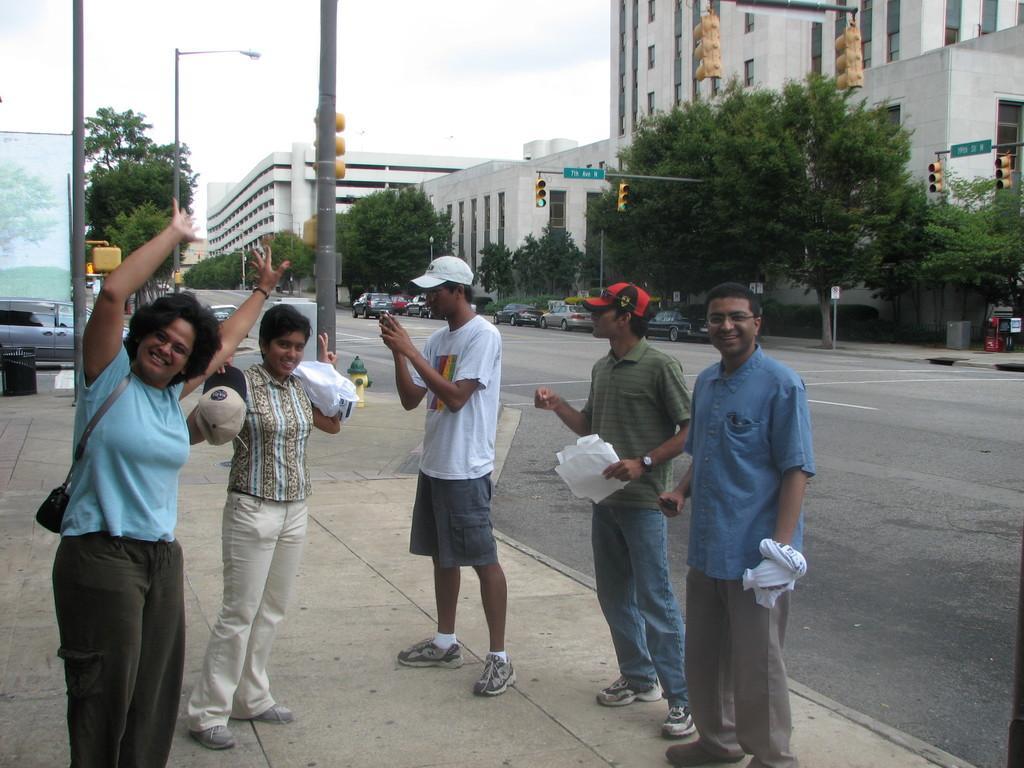In one or two sentences, can you explain what this image depicts? In this picture there is a woman wearing blue T-shirt is standing and raised her hands up and there are few persons standing and holding few objects in their hands beside her and there are few vehicles on the road and there are trees and buildings in the background. 